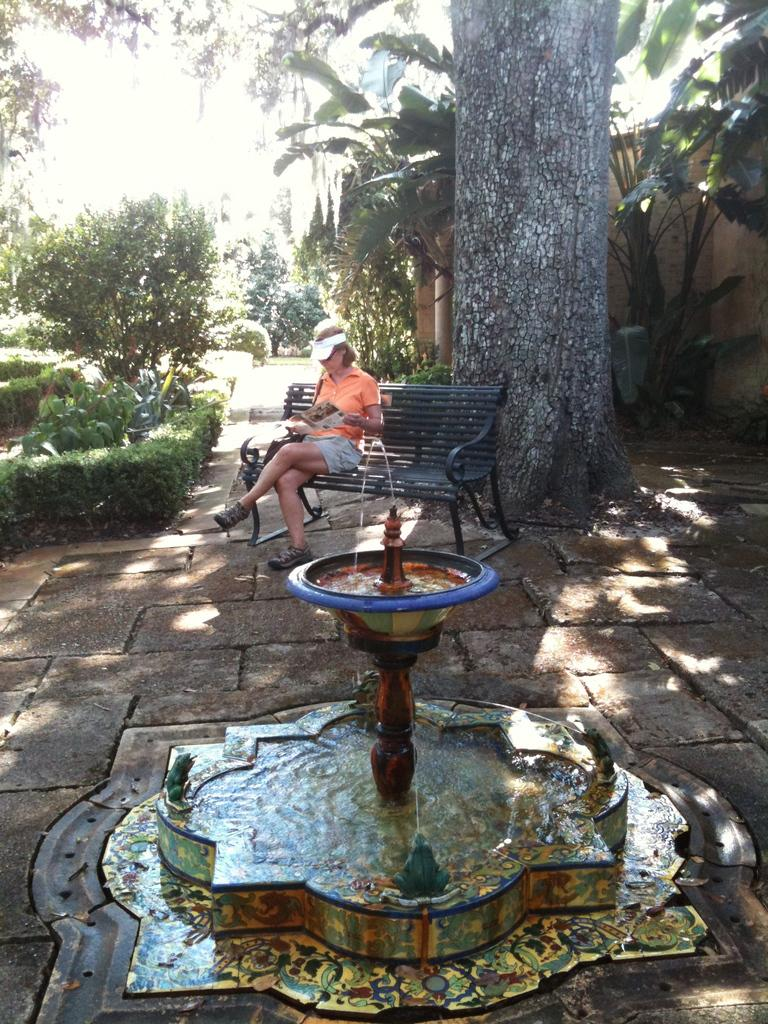What is the main feature in the image? There is a fountain in the image. What can be seen flowing from the fountain? There is water visible in the image. Who is present in the image? There is a woman wearing a cap in the image. What is the woman doing in the image? The woman is sitting on a bench. What can be seen in the background of the image? There are trees in the background of the image. Where is the harbor located in the image? There is no harbor present in the image. What is the woman about to start doing in the image? The image does not show the woman starting any action, as she is already sitting on the bench. 